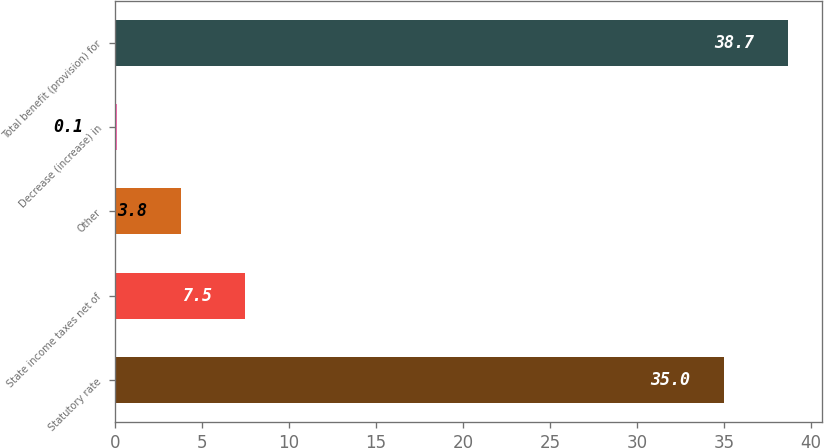Convert chart. <chart><loc_0><loc_0><loc_500><loc_500><bar_chart><fcel>Statutory rate<fcel>State income taxes net of<fcel>Other<fcel>Decrease (increase) in<fcel>Total benefit (provision) for<nl><fcel>35<fcel>7.5<fcel>3.8<fcel>0.1<fcel>38.7<nl></chart> 